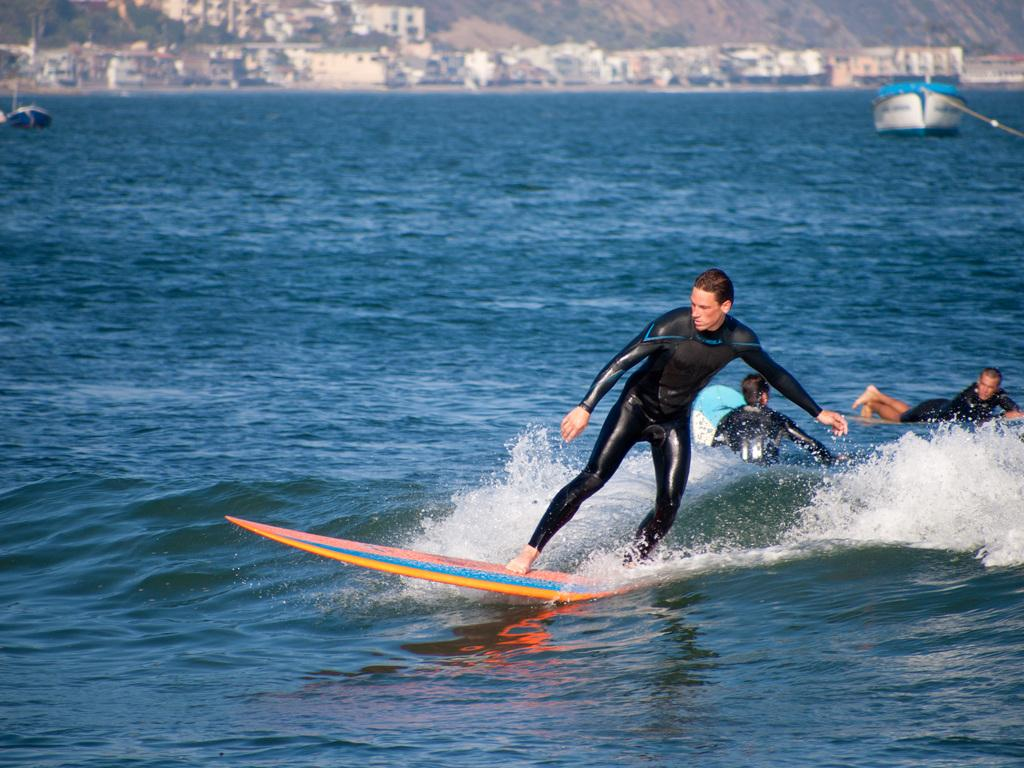What activity are the people engaged in on the water? The people are surfing on the water. What else can be seen on the water in the image? There are boats in a water body. What structures are visible in the background? There is a group of buildings visible in the background. What type of vegetation is present in the image? There are trees present in the image. What type of sheet is being used to cover the yam in the image? There is no sheet or yam present in the image. How many parcels can be seen in the image? There are no parcels visible in the image. 